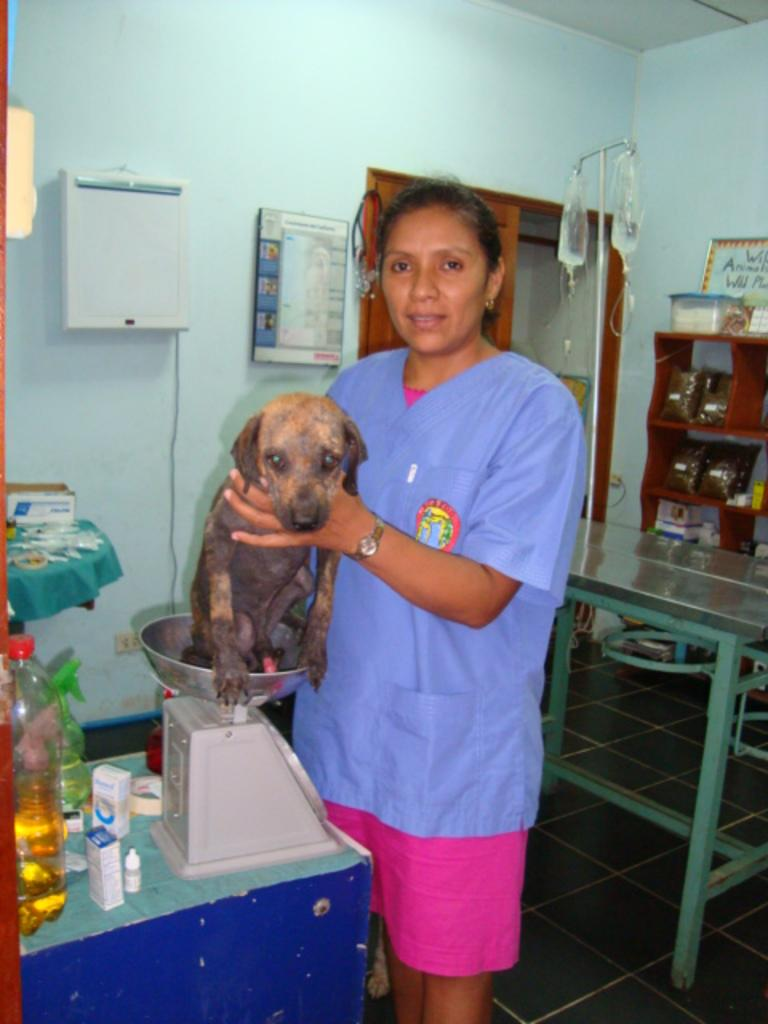Who is present in the image? There is a woman in the image. What is the woman holding in the image? The woman is holding a puppy dog. What is the woman doing in the image? The woman is weighing herself. What else can be seen in the image besides the woman and the puppy dog? There is a bottle with some liquid and hospital machinery or equipment in the image. What type of crate is being used to transport the representative in the image? There is no crate or representative present in the image. 